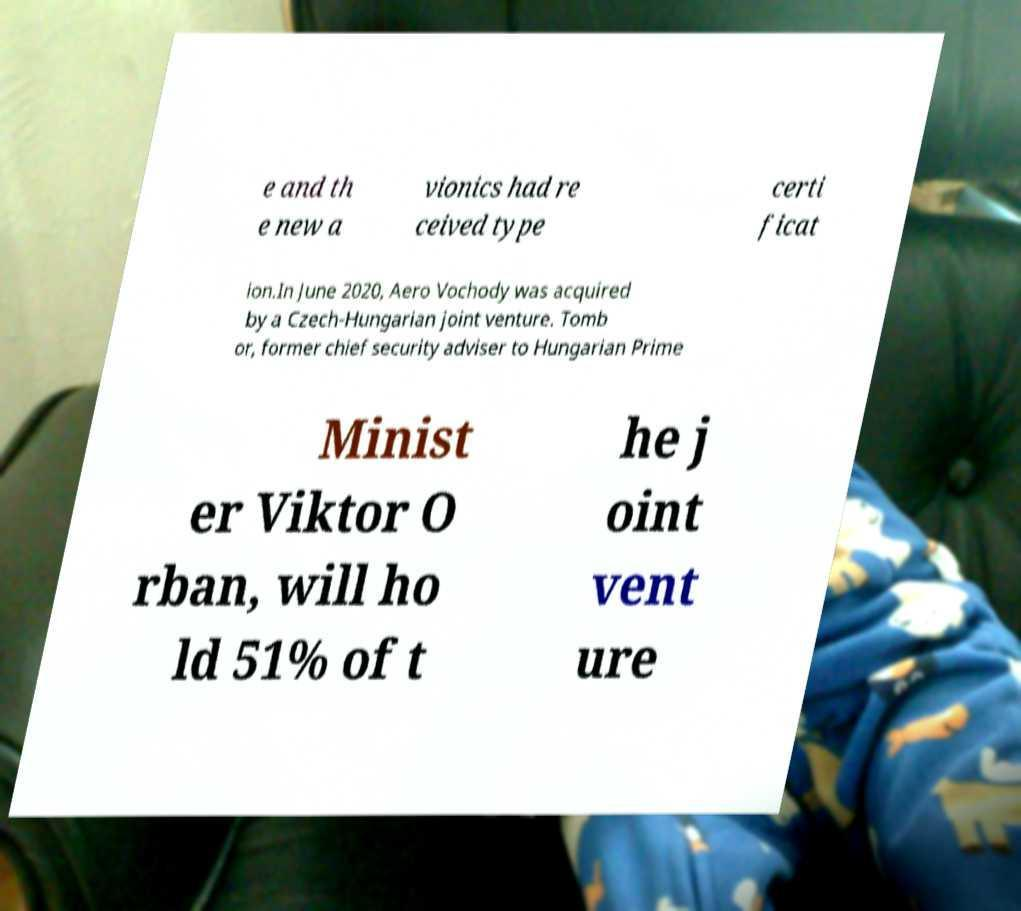What messages or text are displayed in this image? I need them in a readable, typed format. e and th e new a vionics had re ceived type certi ficat ion.In June 2020, Aero Vochody was acquired by a Czech-Hungarian joint venture. Tomb or, former chief security adviser to Hungarian Prime Minist er Viktor O rban, will ho ld 51% of t he j oint vent ure 